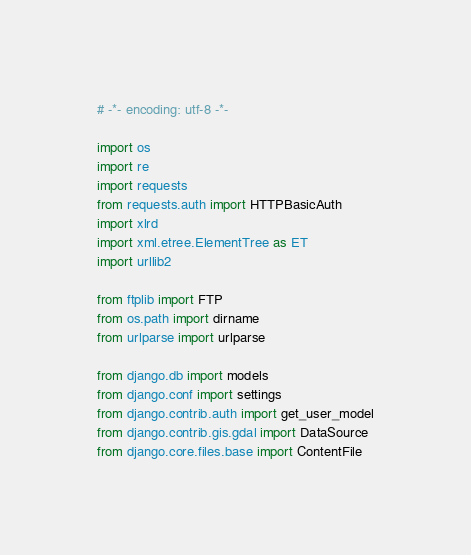Convert code to text. <code><loc_0><loc_0><loc_500><loc_500><_Python_># -*- encoding: utf-8 -*-

import os
import re
import requests
from requests.auth import HTTPBasicAuth
import xlrd
import xml.etree.ElementTree as ET
import urllib2

from ftplib import FTP
from os.path import dirname
from urlparse import urlparse

from django.db import models
from django.conf import settings
from django.contrib.auth import get_user_model
from django.contrib.gis.gdal import DataSource
from django.core.files.base import ContentFile</code> 